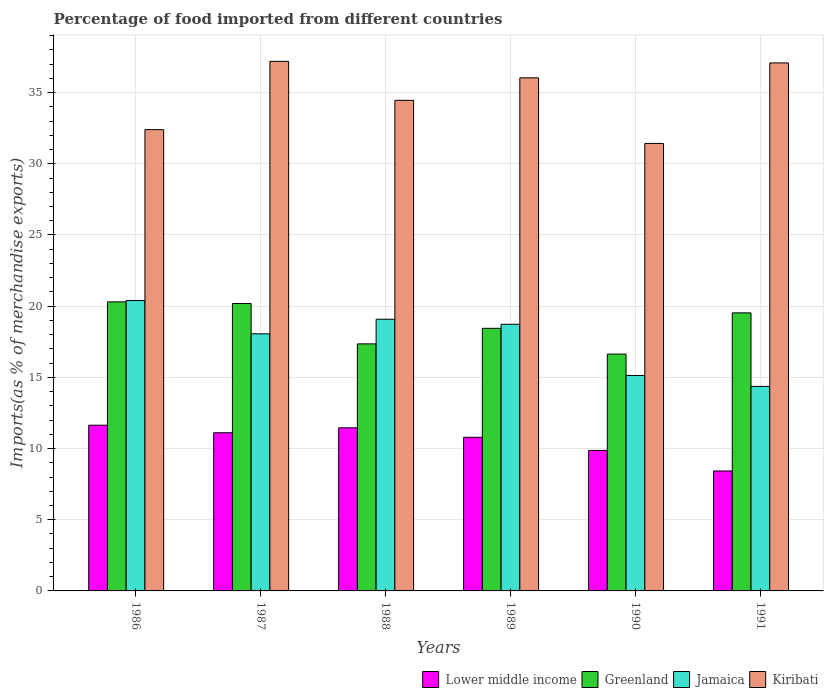How many groups of bars are there?
Your answer should be compact. 6. Are the number of bars per tick equal to the number of legend labels?
Make the answer very short. Yes. Are the number of bars on each tick of the X-axis equal?
Make the answer very short. Yes. How many bars are there on the 6th tick from the right?
Provide a succinct answer. 4. What is the percentage of imports to different countries in Kiribati in 1986?
Provide a short and direct response. 32.4. Across all years, what is the maximum percentage of imports to different countries in Kiribati?
Ensure brevity in your answer.  37.2. Across all years, what is the minimum percentage of imports to different countries in Kiribati?
Ensure brevity in your answer.  31.43. What is the total percentage of imports to different countries in Kiribati in the graph?
Offer a very short reply. 208.61. What is the difference between the percentage of imports to different countries in Kiribati in 1986 and that in 1991?
Provide a succinct answer. -4.68. What is the difference between the percentage of imports to different countries in Greenland in 1989 and the percentage of imports to different countries in Lower middle income in 1990?
Keep it short and to the point. 8.58. What is the average percentage of imports to different countries in Jamaica per year?
Make the answer very short. 17.63. In the year 1991, what is the difference between the percentage of imports to different countries in Greenland and percentage of imports to different countries in Jamaica?
Your response must be concise. 5.16. In how many years, is the percentage of imports to different countries in Jamaica greater than 12 %?
Provide a short and direct response. 6. What is the ratio of the percentage of imports to different countries in Lower middle income in 1986 to that in 1989?
Your response must be concise. 1.08. Is the difference between the percentage of imports to different countries in Greenland in 1987 and 1989 greater than the difference between the percentage of imports to different countries in Jamaica in 1987 and 1989?
Your answer should be very brief. Yes. What is the difference between the highest and the second highest percentage of imports to different countries in Kiribati?
Your response must be concise. 0.11. What is the difference between the highest and the lowest percentage of imports to different countries in Jamaica?
Offer a very short reply. 6.03. Is the sum of the percentage of imports to different countries in Lower middle income in 1987 and 1990 greater than the maximum percentage of imports to different countries in Greenland across all years?
Offer a very short reply. Yes. What does the 2nd bar from the left in 1991 represents?
Provide a short and direct response. Greenland. What does the 2nd bar from the right in 1986 represents?
Keep it short and to the point. Jamaica. Is it the case that in every year, the sum of the percentage of imports to different countries in Kiribati and percentage of imports to different countries in Lower middle income is greater than the percentage of imports to different countries in Greenland?
Your answer should be compact. Yes. How many years are there in the graph?
Provide a short and direct response. 6. What is the difference between two consecutive major ticks on the Y-axis?
Make the answer very short. 5. Does the graph contain any zero values?
Your answer should be very brief. No. How many legend labels are there?
Provide a succinct answer. 4. What is the title of the graph?
Keep it short and to the point. Percentage of food imported from different countries. Does "Italy" appear as one of the legend labels in the graph?
Ensure brevity in your answer.  No. What is the label or title of the Y-axis?
Make the answer very short. Imports(as % of merchandise exports). What is the Imports(as % of merchandise exports) in Lower middle income in 1986?
Offer a terse response. 11.64. What is the Imports(as % of merchandise exports) in Greenland in 1986?
Make the answer very short. 20.3. What is the Imports(as % of merchandise exports) of Jamaica in 1986?
Keep it short and to the point. 20.4. What is the Imports(as % of merchandise exports) of Kiribati in 1986?
Make the answer very short. 32.4. What is the Imports(as % of merchandise exports) in Lower middle income in 1987?
Ensure brevity in your answer.  11.11. What is the Imports(as % of merchandise exports) in Greenland in 1987?
Provide a succinct answer. 20.19. What is the Imports(as % of merchandise exports) of Jamaica in 1987?
Provide a short and direct response. 18.06. What is the Imports(as % of merchandise exports) of Kiribati in 1987?
Ensure brevity in your answer.  37.2. What is the Imports(as % of merchandise exports) in Lower middle income in 1988?
Keep it short and to the point. 11.46. What is the Imports(as % of merchandise exports) of Greenland in 1988?
Provide a short and direct response. 17.35. What is the Imports(as % of merchandise exports) in Jamaica in 1988?
Keep it short and to the point. 19.08. What is the Imports(as % of merchandise exports) in Kiribati in 1988?
Your response must be concise. 34.46. What is the Imports(as % of merchandise exports) in Lower middle income in 1989?
Offer a very short reply. 10.79. What is the Imports(as % of merchandise exports) in Greenland in 1989?
Make the answer very short. 18.45. What is the Imports(as % of merchandise exports) in Jamaica in 1989?
Your response must be concise. 18.73. What is the Imports(as % of merchandise exports) in Kiribati in 1989?
Your answer should be very brief. 36.04. What is the Imports(as % of merchandise exports) of Lower middle income in 1990?
Ensure brevity in your answer.  9.87. What is the Imports(as % of merchandise exports) in Greenland in 1990?
Your answer should be compact. 16.64. What is the Imports(as % of merchandise exports) of Jamaica in 1990?
Offer a terse response. 15.13. What is the Imports(as % of merchandise exports) in Kiribati in 1990?
Your answer should be compact. 31.43. What is the Imports(as % of merchandise exports) of Lower middle income in 1991?
Your response must be concise. 8.43. What is the Imports(as % of merchandise exports) of Greenland in 1991?
Provide a short and direct response. 19.53. What is the Imports(as % of merchandise exports) of Jamaica in 1991?
Your answer should be compact. 14.37. What is the Imports(as % of merchandise exports) in Kiribati in 1991?
Provide a succinct answer. 37.09. Across all years, what is the maximum Imports(as % of merchandise exports) in Lower middle income?
Your answer should be very brief. 11.64. Across all years, what is the maximum Imports(as % of merchandise exports) in Greenland?
Provide a succinct answer. 20.3. Across all years, what is the maximum Imports(as % of merchandise exports) of Jamaica?
Offer a very short reply. 20.4. Across all years, what is the maximum Imports(as % of merchandise exports) in Kiribati?
Provide a short and direct response. 37.2. Across all years, what is the minimum Imports(as % of merchandise exports) in Lower middle income?
Your answer should be compact. 8.43. Across all years, what is the minimum Imports(as % of merchandise exports) in Greenland?
Provide a succinct answer. 16.64. Across all years, what is the minimum Imports(as % of merchandise exports) of Jamaica?
Make the answer very short. 14.37. Across all years, what is the minimum Imports(as % of merchandise exports) in Kiribati?
Give a very brief answer. 31.43. What is the total Imports(as % of merchandise exports) in Lower middle income in the graph?
Provide a short and direct response. 63.29. What is the total Imports(as % of merchandise exports) in Greenland in the graph?
Your answer should be very brief. 112.45. What is the total Imports(as % of merchandise exports) of Jamaica in the graph?
Ensure brevity in your answer.  105.77. What is the total Imports(as % of merchandise exports) of Kiribati in the graph?
Offer a very short reply. 208.61. What is the difference between the Imports(as % of merchandise exports) of Lower middle income in 1986 and that in 1987?
Ensure brevity in your answer.  0.53. What is the difference between the Imports(as % of merchandise exports) in Greenland in 1986 and that in 1987?
Give a very brief answer. 0.11. What is the difference between the Imports(as % of merchandise exports) of Jamaica in 1986 and that in 1987?
Offer a very short reply. 2.34. What is the difference between the Imports(as % of merchandise exports) of Kiribati in 1986 and that in 1987?
Give a very brief answer. -4.8. What is the difference between the Imports(as % of merchandise exports) in Lower middle income in 1986 and that in 1988?
Offer a terse response. 0.18. What is the difference between the Imports(as % of merchandise exports) of Greenland in 1986 and that in 1988?
Offer a terse response. 2.95. What is the difference between the Imports(as % of merchandise exports) in Jamaica in 1986 and that in 1988?
Offer a terse response. 1.31. What is the difference between the Imports(as % of merchandise exports) in Kiribati in 1986 and that in 1988?
Give a very brief answer. -2.06. What is the difference between the Imports(as % of merchandise exports) of Lower middle income in 1986 and that in 1989?
Offer a very short reply. 0.85. What is the difference between the Imports(as % of merchandise exports) in Greenland in 1986 and that in 1989?
Provide a succinct answer. 1.86. What is the difference between the Imports(as % of merchandise exports) in Jamaica in 1986 and that in 1989?
Offer a very short reply. 1.66. What is the difference between the Imports(as % of merchandise exports) in Kiribati in 1986 and that in 1989?
Offer a very short reply. -3.64. What is the difference between the Imports(as % of merchandise exports) in Lower middle income in 1986 and that in 1990?
Offer a very short reply. 1.77. What is the difference between the Imports(as % of merchandise exports) of Greenland in 1986 and that in 1990?
Make the answer very short. 3.67. What is the difference between the Imports(as % of merchandise exports) of Jamaica in 1986 and that in 1990?
Ensure brevity in your answer.  5.26. What is the difference between the Imports(as % of merchandise exports) of Kiribati in 1986 and that in 1990?
Your response must be concise. 0.97. What is the difference between the Imports(as % of merchandise exports) of Lower middle income in 1986 and that in 1991?
Your answer should be compact. 3.21. What is the difference between the Imports(as % of merchandise exports) of Greenland in 1986 and that in 1991?
Keep it short and to the point. 0.77. What is the difference between the Imports(as % of merchandise exports) in Jamaica in 1986 and that in 1991?
Keep it short and to the point. 6.03. What is the difference between the Imports(as % of merchandise exports) of Kiribati in 1986 and that in 1991?
Offer a very short reply. -4.68. What is the difference between the Imports(as % of merchandise exports) of Lower middle income in 1987 and that in 1988?
Provide a succinct answer. -0.35. What is the difference between the Imports(as % of merchandise exports) of Greenland in 1987 and that in 1988?
Offer a terse response. 2.83. What is the difference between the Imports(as % of merchandise exports) of Jamaica in 1987 and that in 1988?
Ensure brevity in your answer.  -1.02. What is the difference between the Imports(as % of merchandise exports) of Kiribati in 1987 and that in 1988?
Make the answer very short. 2.74. What is the difference between the Imports(as % of merchandise exports) of Lower middle income in 1987 and that in 1989?
Offer a terse response. 0.32. What is the difference between the Imports(as % of merchandise exports) in Greenland in 1987 and that in 1989?
Provide a succinct answer. 1.74. What is the difference between the Imports(as % of merchandise exports) in Jamaica in 1987 and that in 1989?
Ensure brevity in your answer.  -0.67. What is the difference between the Imports(as % of merchandise exports) of Kiribati in 1987 and that in 1989?
Offer a terse response. 1.16. What is the difference between the Imports(as % of merchandise exports) of Lower middle income in 1987 and that in 1990?
Your answer should be compact. 1.24. What is the difference between the Imports(as % of merchandise exports) in Greenland in 1987 and that in 1990?
Your response must be concise. 3.55. What is the difference between the Imports(as % of merchandise exports) in Jamaica in 1987 and that in 1990?
Offer a very short reply. 2.92. What is the difference between the Imports(as % of merchandise exports) of Kiribati in 1987 and that in 1990?
Ensure brevity in your answer.  5.76. What is the difference between the Imports(as % of merchandise exports) in Lower middle income in 1987 and that in 1991?
Give a very brief answer. 2.68. What is the difference between the Imports(as % of merchandise exports) in Greenland in 1987 and that in 1991?
Your answer should be very brief. 0.66. What is the difference between the Imports(as % of merchandise exports) of Jamaica in 1987 and that in 1991?
Your answer should be compact. 3.69. What is the difference between the Imports(as % of merchandise exports) in Kiribati in 1987 and that in 1991?
Make the answer very short. 0.11. What is the difference between the Imports(as % of merchandise exports) of Lower middle income in 1988 and that in 1989?
Offer a very short reply. 0.66. What is the difference between the Imports(as % of merchandise exports) in Greenland in 1988 and that in 1989?
Make the answer very short. -1.09. What is the difference between the Imports(as % of merchandise exports) of Jamaica in 1988 and that in 1989?
Give a very brief answer. 0.35. What is the difference between the Imports(as % of merchandise exports) of Kiribati in 1988 and that in 1989?
Keep it short and to the point. -1.58. What is the difference between the Imports(as % of merchandise exports) in Lower middle income in 1988 and that in 1990?
Offer a terse response. 1.59. What is the difference between the Imports(as % of merchandise exports) of Greenland in 1988 and that in 1990?
Keep it short and to the point. 0.72. What is the difference between the Imports(as % of merchandise exports) in Jamaica in 1988 and that in 1990?
Provide a succinct answer. 3.95. What is the difference between the Imports(as % of merchandise exports) of Kiribati in 1988 and that in 1990?
Keep it short and to the point. 3.03. What is the difference between the Imports(as % of merchandise exports) of Lower middle income in 1988 and that in 1991?
Offer a very short reply. 3.03. What is the difference between the Imports(as % of merchandise exports) in Greenland in 1988 and that in 1991?
Give a very brief answer. -2.18. What is the difference between the Imports(as % of merchandise exports) in Jamaica in 1988 and that in 1991?
Your answer should be very brief. 4.72. What is the difference between the Imports(as % of merchandise exports) in Kiribati in 1988 and that in 1991?
Provide a succinct answer. -2.63. What is the difference between the Imports(as % of merchandise exports) in Lower middle income in 1989 and that in 1990?
Your answer should be very brief. 0.92. What is the difference between the Imports(as % of merchandise exports) of Greenland in 1989 and that in 1990?
Provide a short and direct response. 1.81. What is the difference between the Imports(as % of merchandise exports) in Jamaica in 1989 and that in 1990?
Make the answer very short. 3.6. What is the difference between the Imports(as % of merchandise exports) of Kiribati in 1989 and that in 1990?
Ensure brevity in your answer.  4.61. What is the difference between the Imports(as % of merchandise exports) in Lower middle income in 1989 and that in 1991?
Offer a very short reply. 2.36. What is the difference between the Imports(as % of merchandise exports) of Greenland in 1989 and that in 1991?
Provide a succinct answer. -1.08. What is the difference between the Imports(as % of merchandise exports) of Jamaica in 1989 and that in 1991?
Make the answer very short. 4.36. What is the difference between the Imports(as % of merchandise exports) in Kiribati in 1989 and that in 1991?
Ensure brevity in your answer.  -1.05. What is the difference between the Imports(as % of merchandise exports) in Lower middle income in 1990 and that in 1991?
Provide a short and direct response. 1.44. What is the difference between the Imports(as % of merchandise exports) in Greenland in 1990 and that in 1991?
Ensure brevity in your answer.  -2.89. What is the difference between the Imports(as % of merchandise exports) of Jamaica in 1990 and that in 1991?
Provide a short and direct response. 0.77. What is the difference between the Imports(as % of merchandise exports) of Kiribati in 1990 and that in 1991?
Offer a very short reply. -5.65. What is the difference between the Imports(as % of merchandise exports) in Lower middle income in 1986 and the Imports(as % of merchandise exports) in Greenland in 1987?
Your answer should be very brief. -8.55. What is the difference between the Imports(as % of merchandise exports) in Lower middle income in 1986 and the Imports(as % of merchandise exports) in Jamaica in 1987?
Offer a very short reply. -6.42. What is the difference between the Imports(as % of merchandise exports) of Lower middle income in 1986 and the Imports(as % of merchandise exports) of Kiribati in 1987?
Offer a terse response. -25.56. What is the difference between the Imports(as % of merchandise exports) of Greenland in 1986 and the Imports(as % of merchandise exports) of Jamaica in 1987?
Keep it short and to the point. 2.24. What is the difference between the Imports(as % of merchandise exports) in Greenland in 1986 and the Imports(as % of merchandise exports) in Kiribati in 1987?
Ensure brevity in your answer.  -16.89. What is the difference between the Imports(as % of merchandise exports) of Jamaica in 1986 and the Imports(as % of merchandise exports) of Kiribati in 1987?
Ensure brevity in your answer.  -16.8. What is the difference between the Imports(as % of merchandise exports) in Lower middle income in 1986 and the Imports(as % of merchandise exports) in Greenland in 1988?
Your answer should be very brief. -5.71. What is the difference between the Imports(as % of merchandise exports) of Lower middle income in 1986 and the Imports(as % of merchandise exports) of Jamaica in 1988?
Your answer should be compact. -7.44. What is the difference between the Imports(as % of merchandise exports) in Lower middle income in 1986 and the Imports(as % of merchandise exports) in Kiribati in 1988?
Keep it short and to the point. -22.82. What is the difference between the Imports(as % of merchandise exports) in Greenland in 1986 and the Imports(as % of merchandise exports) in Jamaica in 1988?
Give a very brief answer. 1.22. What is the difference between the Imports(as % of merchandise exports) in Greenland in 1986 and the Imports(as % of merchandise exports) in Kiribati in 1988?
Make the answer very short. -14.16. What is the difference between the Imports(as % of merchandise exports) of Jamaica in 1986 and the Imports(as % of merchandise exports) of Kiribati in 1988?
Keep it short and to the point. -14.06. What is the difference between the Imports(as % of merchandise exports) in Lower middle income in 1986 and the Imports(as % of merchandise exports) in Greenland in 1989?
Give a very brief answer. -6.81. What is the difference between the Imports(as % of merchandise exports) of Lower middle income in 1986 and the Imports(as % of merchandise exports) of Jamaica in 1989?
Keep it short and to the point. -7.09. What is the difference between the Imports(as % of merchandise exports) of Lower middle income in 1986 and the Imports(as % of merchandise exports) of Kiribati in 1989?
Your answer should be compact. -24.4. What is the difference between the Imports(as % of merchandise exports) of Greenland in 1986 and the Imports(as % of merchandise exports) of Jamaica in 1989?
Provide a short and direct response. 1.57. What is the difference between the Imports(as % of merchandise exports) of Greenland in 1986 and the Imports(as % of merchandise exports) of Kiribati in 1989?
Offer a very short reply. -15.74. What is the difference between the Imports(as % of merchandise exports) of Jamaica in 1986 and the Imports(as % of merchandise exports) of Kiribati in 1989?
Offer a very short reply. -15.64. What is the difference between the Imports(as % of merchandise exports) of Lower middle income in 1986 and the Imports(as % of merchandise exports) of Greenland in 1990?
Offer a terse response. -5. What is the difference between the Imports(as % of merchandise exports) in Lower middle income in 1986 and the Imports(as % of merchandise exports) in Jamaica in 1990?
Ensure brevity in your answer.  -3.49. What is the difference between the Imports(as % of merchandise exports) in Lower middle income in 1986 and the Imports(as % of merchandise exports) in Kiribati in 1990?
Provide a short and direct response. -19.79. What is the difference between the Imports(as % of merchandise exports) of Greenland in 1986 and the Imports(as % of merchandise exports) of Jamaica in 1990?
Offer a terse response. 5.17. What is the difference between the Imports(as % of merchandise exports) in Greenland in 1986 and the Imports(as % of merchandise exports) in Kiribati in 1990?
Offer a very short reply. -11.13. What is the difference between the Imports(as % of merchandise exports) of Jamaica in 1986 and the Imports(as % of merchandise exports) of Kiribati in 1990?
Offer a very short reply. -11.04. What is the difference between the Imports(as % of merchandise exports) in Lower middle income in 1986 and the Imports(as % of merchandise exports) in Greenland in 1991?
Offer a terse response. -7.89. What is the difference between the Imports(as % of merchandise exports) in Lower middle income in 1986 and the Imports(as % of merchandise exports) in Jamaica in 1991?
Your answer should be compact. -2.73. What is the difference between the Imports(as % of merchandise exports) in Lower middle income in 1986 and the Imports(as % of merchandise exports) in Kiribati in 1991?
Give a very brief answer. -25.45. What is the difference between the Imports(as % of merchandise exports) of Greenland in 1986 and the Imports(as % of merchandise exports) of Jamaica in 1991?
Ensure brevity in your answer.  5.93. What is the difference between the Imports(as % of merchandise exports) of Greenland in 1986 and the Imports(as % of merchandise exports) of Kiribati in 1991?
Give a very brief answer. -16.78. What is the difference between the Imports(as % of merchandise exports) of Jamaica in 1986 and the Imports(as % of merchandise exports) of Kiribati in 1991?
Give a very brief answer. -16.69. What is the difference between the Imports(as % of merchandise exports) in Lower middle income in 1987 and the Imports(as % of merchandise exports) in Greenland in 1988?
Ensure brevity in your answer.  -6.24. What is the difference between the Imports(as % of merchandise exports) of Lower middle income in 1987 and the Imports(as % of merchandise exports) of Jamaica in 1988?
Make the answer very short. -7.97. What is the difference between the Imports(as % of merchandise exports) in Lower middle income in 1987 and the Imports(as % of merchandise exports) in Kiribati in 1988?
Your answer should be compact. -23.35. What is the difference between the Imports(as % of merchandise exports) in Greenland in 1987 and the Imports(as % of merchandise exports) in Jamaica in 1988?
Keep it short and to the point. 1.1. What is the difference between the Imports(as % of merchandise exports) of Greenland in 1987 and the Imports(as % of merchandise exports) of Kiribati in 1988?
Your answer should be compact. -14.27. What is the difference between the Imports(as % of merchandise exports) in Jamaica in 1987 and the Imports(as % of merchandise exports) in Kiribati in 1988?
Your answer should be compact. -16.4. What is the difference between the Imports(as % of merchandise exports) of Lower middle income in 1987 and the Imports(as % of merchandise exports) of Greenland in 1989?
Your answer should be very brief. -7.34. What is the difference between the Imports(as % of merchandise exports) in Lower middle income in 1987 and the Imports(as % of merchandise exports) in Jamaica in 1989?
Your response must be concise. -7.62. What is the difference between the Imports(as % of merchandise exports) of Lower middle income in 1987 and the Imports(as % of merchandise exports) of Kiribati in 1989?
Your answer should be compact. -24.93. What is the difference between the Imports(as % of merchandise exports) in Greenland in 1987 and the Imports(as % of merchandise exports) in Jamaica in 1989?
Provide a succinct answer. 1.46. What is the difference between the Imports(as % of merchandise exports) in Greenland in 1987 and the Imports(as % of merchandise exports) in Kiribati in 1989?
Your answer should be compact. -15.85. What is the difference between the Imports(as % of merchandise exports) of Jamaica in 1987 and the Imports(as % of merchandise exports) of Kiribati in 1989?
Your answer should be compact. -17.98. What is the difference between the Imports(as % of merchandise exports) of Lower middle income in 1987 and the Imports(as % of merchandise exports) of Greenland in 1990?
Ensure brevity in your answer.  -5.53. What is the difference between the Imports(as % of merchandise exports) in Lower middle income in 1987 and the Imports(as % of merchandise exports) in Jamaica in 1990?
Give a very brief answer. -4.02. What is the difference between the Imports(as % of merchandise exports) of Lower middle income in 1987 and the Imports(as % of merchandise exports) of Kiribati in 1990?
Provide a succinct answer. -20.32. What is the difference between the Imports(as % of merchandise exports) of Greenland in 1987 and the Imports(as % of merchandise exports) of Jamaica in 1990?
Keep it short and to the point. 5.05. What is the difference between the Imports(as % of merchandise exports) in Greenland in 1987 and the Imports(as % of merchandise exports) in Kiribati in 1990?
Provide a short and direct response. -11.25. What is the difference between the Imports(as % of merchandise exports) in Jamaica in 1987 and the Imports(as % of merchandise exports) in Kiribati in 1990?
Ensure brevity in your answer.  -13.37. What is the difference between the Imports(as % of merchandise exports) in Lower middle income in 1987 and the Imports(as % of merchandise exports) in Greenland in 1991?
Your response must be concise. -8.42. What is the difference between the Imports(as % of merchandise exports) of Lower middle income in 1987 and the Imports(as % of merchandise exports) of Jamaica in 1991?
Your answer should be very brief. -3.26. What is the difference between the Imports(as % of merchandise exports) in Lower middle income in 1987 and the Imports(as % of merchandise exports) in Kiribati in 1991?
Your response must be concise. -25.98. What is the difference between the Imports(as % of merchandise exports) in Greenland in 1987 and the Imports(as % of merchandise exports) in Jamaica in 1991?
Your response must be concise. 5.82. What is the difference between the Imports(as % of merchandise exports) in Greenland in 1987 and the Imports(as % of merchandise exports) in Kiribati in 1991?
Give a very brief answer. -16.9. What is the difference between the Imports(as % of merchandise exports) in Jamaica in 1987 and the Imports(as % of merchandise exports) in Kiribati in 1991?
Give a very brief answer. -19.03. What is the difference between the Imports(as % of merchandise exports) of Lower middle income in 1988 and the Imports(as % of merchandise exports) of Greenland in 1989?
Ensure brevity in your answer.  -6.99. What is the difference between the Imports(as % of merchandise exports) in Lower middle income in 1988 and the Imports(as % of merchandise exports) in Jamaica in 1989?
Provide a succinct answer. -7.27. What is the difference between the Imports(as % of merchandise exports) of Lower middle income in 1988 and the Imports(as % of merchandise exports) of Kiribati in 1989?
Give a very brief answer. -24.58. What is the difference between the Imports(as % of merchandise exports) in Greenland in 1988 and the Imports(as % of merchandise exports) in Jamaica in 1989?
Keep it short and to the point. -1.38. What is the difference between the Imports(as % of merchandise exports) of Greenland in 1988 and the Imports(as % of merchandise exports) of Kiribati in 1989?
Ensure brevity in your answer.  -18.69. What is the difference between the Imports(as % of merchandise exports) of Jamaica in 1988 and the Imports(as % of merchandise exports) of Kiribati in 1989?
Your answer should be very brief. -16.96. What is the difference between the Imports(as % of merchandise exports) of Lower middle income in 1988 and the Imports(as % of merchandise exports) of Greenland in 1990?
Offer a terse response. -5.18. What is the difference between the Imports(as % of merchandise exports) of Lower middle income in 1988 and the Imports(as % of merchandise exports) of Jamaica in 1990?
Your response must be concise. -3.68. What is the difference between the Imports(as % of merchandise exports) of Lower middle income in 1988 and the Imports(as % of merchandise exports) of Kiribati in 1990?
Ensure brevity in your answer.  -19.98. What is the difference between the Imports(as % of merchandise exports) in Greenland in 1988 and the Imports(as % of merchandise exports) in Jamaica in 1990?
Offer a terse response. 2.22. What is the difference between the Imports(as % of merchandise exports) in Greenland in 1988 and the Imports(as % of merchandise exports) in Kiribati in 1990?
Offer a very short reply. -14.08. What is the difference between the Imports(as % of merchandise exports) in Jamaica in 1988 and the Imports(as % of merchandise exports) in Kiribati in 1990?
Provide a short and direct response. -12.35. What is the difference between the Imports(as % of merchandise exports) of Lower middle income in 1988 and the Imports(as % of merchandise exports) of Greenland in 1991?
Offer a very short reply. -8.07. What is the difference between the Imports(as % of merchandise exports) in Lower middle income in 1988 and the Imports(as % of merchandise exports) in Jamaica in 1991?
Your response must be concise. -2.91. What is the difference between the Imports(as % of merchandise exports) in Lower middle income in 1988 and the Imports(as % of merchandise exports) in Kiribati in 1991?
Give a very brief answer. -25.63. What is the difference between the Imports(as % of merchandise exports) in Greenland in 1988 and the Imports(as % of merchandise exports) in Jamaica in 1991?
Ensure brevity in your answer.  2.99. What is the difference between the Imports(as % of merchandise exports) in Greenland in 1988 and the Imports(as % of merchandise exports) in Kiribati in 1991?
Ensure brevity in your answer.  -19.73. What is the difference between the Imports(as % of merchandise exports) in Jamaica in 1988 and the Imports(as % of merchandise exports) in Kiribati in 1991?
Provide a succinct answer. -18. What is the difference between the Imports(as % of merchandise exports) of Lower middle income in 1989 and the Imports(as % of merchandise exports) of Greenland in 1990?
Give a very brief answer. -5.85. What is the difference between the Imports(as % of merchandise exports) in Lower middle income in 1989 and the Imports(as % of merchandise exports) in Jamaica in 1990?
Offer a terse response. -4.34. What is the difference between the Imports(as % of merchandise exports) of Lower middle income in 1989 and the Imports(as % of merchandise exports) of Kiribati in 1990?
Your answer should be compact. -20.64. What is the difference between the Imports(as % of merchandise exports) of Greenland in 1989 and the Imports(as % of merchandise exports) of Jamaica in 1990?
Give a very brief answer. 3.31. What is the difference between the Imports(as % of merchandise exports) in Greenland in 1989 and the Imports(as % of merchandise exports) in Kiribati in 1990?
Make the answer very short. -12.99. What is the difference between the Imports(as % of merchandise exports) in Jamaica in 1989 and the Imports(as % of merchandise exports) in Kiribati in 1990?
Make the answer very short. -12.7. What is the difference between the Imports(as % of merchandise exports) in Lower middle income in 1989 and the Imports(as % of merchandise exports) in Greenland in 1991?
Your answer should be compact. -8.74. What is the difference between the Imports(as % of merchandise exports) in Lower middle income in 1989 and the Imports(as % of merchandise exports) in Jamaica in 1991?
Your response must be concise. -3.58. What is the difference between the Imports(as % of merchandise exports) of Lower middle income in 1989 and the Imports(as % of merchandise exports) of Kiribati in 1991?
Provide a succinct answer. -26.29. What is the difference between the Imports(as % of merchandise exports) of Greenland in 1989 and the Imports(as % of merchandise exports) of Jamaica in 1991?
Offer a very short reply. 4.08. What is the difference between the Imports(as % of merchandise exports) of Greenland in 1989 and the Imports(as % of merchandise exports) of Kiribati in 1991?
Keep it short and to the point. -18.64. What is the difference between the Imports(as % of merchandise exports) in Jamaica in 1989 and the Imports(as % of merchandise exports) in Kiribati in 1991?
Provide a short and direct response. -18.36. What is the difference between the Imports(as % of merchandise exports) of Lower middle income in 1990 and the Imports(as % of merchandise exports) of Greenland in 1991?
Keep it short and to the point. -9.66. What is the difference between the Imports(as % of merchandise exports) in Lower middle income in 1990 and the Imports(as % of merchandise exports) in Jamaica in 1991?
Ensure brevity in your answer.  -4.5. What is the difference between the Imports(as % of merchandise exports) in Lower middle income in 1990 and the Imports(as % of merchandise exports) in Kiribati in 1991?
Make the answer very short. -27.22. What is the difference between the Imports(as % of merchandise exports) in Greenland in 1990 and the Imports(as % of merchandise exports) in Jamaica in 1991?
Your answer should be very brief. 2.27. What is the difference between the Imports(as % of merchandise exports) in Greenland in 1990 and the Imports(as % of merchandise exports) in Kiribati in 1991?
Offer a terse response. -20.45. What is the difference between the Imports(as % of merchandise exports) in Jamaica in 1990 and the Imports(as % of merchandise exports) in Kiribati in 1991?
Make the answer very short. -21.95. What is the average Imports(as % of merchandise exports) in Lower middle income per year?
Keep it short and to the point. 10.55. What is the average Imports(as % of merchandise exports) in Greenland per year?
Offer a very short reply. 18.74. What is the average Imports(as % of merchandise exports) of Jamaica per year?
Give a very brief answer. 17.63. What is the average Imports(as % of merchandise exports) of Kiribati per year?
Ensure brevity in your answer.  34.77. In the year 1986, what is the difference between the Imports(as % of merchandise exports) of Lower middle income and Imports(as % of merchandise exports) of Greenland?
Provide a short and direct response. -8.66. In the year 1986, what is the difference between the Imports(as % of merchandise exports) of Lower middle income and Imports(as % of merchandise exports) of Jamaica?
Offer a terse response. -8.76. In the year 1986, what is the difference between the Imports(as % of merchandise exports) of Lower middle income and Imports(as % of merchandise exports) of Kiribati?
Your answer should be compact. -20.76. In the year 1986, what is the difference between the Imports(as % of merchandise exports) in Greenland and Imports(as % of merchandise exports) in Jamaica?
Your answer should be compact. -0.09. In the year 1986, what is the difference between the Imports(as % of merchandise exports) of Greenland and Imports(as % of merchandise exports) of Kiribati?
Offer a very short reply. -12.1. In the year 1986, what is the difference between the Imports(as % of merchandise exports) in Jamaica and Imports(as % of merchandise exports) in Kiribati?
Offer a terse response. -12.01. In the year 1987, what is the difference between the Imports(as % of merchandise exports) in Lower middle income and Imports(as % of merchandise exports) in Greenland?
Ensure brevity in your answer.  -9.08. In the year 1987, what is the difference between the Imports(as % of merchandise exports) of Lower middle income and Imports(as % of merchandise exports) of Jamaica?
Your response must be concise. -6.95. In the year 1987, what is the difference between the Imports(as % of merchandise exports) of Lower middle income and Imports(as % of merchandise exports) of Kiribati?
Offer a terse response. -26.09. In the year 1987, what is the difference between the Imports(as % of merchandise exports) in Greenland and Imports(as % of merchandise exports) in Jamaica?
Provide a short and direct response. 2.13. In the year 1987, what is the difference between the Imports(as % of merchandise exports) in Greenland and Imports(as % of merchandise exports) in Kiribati?
Your response must be concise. -17.01. In the year 1987, what is the difference between the Imports(as % of merchandise exports) in Jamaica and Imports(as % of merchandise exports) in Kiribati?
Your answer should be very brief. -19.14. In the year 1988, what is the difference between the Imports(as % of merchandise exports) of Lower middle income and Imports(as % of merchandise exports) of Greenland?
Offer a very short reply. -5.9. In the year 1988, what is the difference between the Imports(as % of merchandise exports) of Lower middle income and Imports(as % of merchandise exports) of Jamaica?
Offer a very short reply. -7.63. In the year 1988, what is the difference between the Imports(as % of merchandise exports) in Lower middle income and Imports(as % of merchandise exports) in Kiribati?
Make the answer very short. -23. In the year 1988, what is the difference between the Imports(as % of merchandise exports) of Greenland and Imports(as % of merchandise exports) of Jamaica?
Keep it short and to the point. -1.73. In the year 1988, what is the difference between the Imports(as % of merchandise exports) in Greenland and Imports(as % of merchandise exports) in Kiribati?
Offer a terse response. -17.11. In the year 1988, what is the difference between the Imports(as % of merchandise exports) in Jamaica and Imports(as % of merchandise exports) in Kiribati?
Give a very brief answer. -15.38. In the year 1989, what is the difference between the Imports(as % of merchandise exports) of Lower middle income and Imports(as % of merchandise exports) of Greenland?
Offer a terse response. -7.65. In the year 1989, what is the difference between the Imports(as % of merchandise exports) of Lower middle income and Imports(as % of merchandise exports) of Jamaica?
Ensure brevity in your answer.  -7.94. In the year 1989, what is the difference between the Imports(as % of merchandise exports) of Lower middle income and Imports(as % of merchandise exports) of Kiribati?
Ensure brevity in your answer.  -25.25. In the year 1989, what is the difference between the Imports(as % of merchandise exports) in Greenland and Imports(as % of merchandise exports) in Jamaica?
Keep it short and to the point. -0.29. In the year 1989, what is the difference between the Imports(as % of merchandise exports) of Greenland and Imports(as % of merchandise exports) of Kiribati?
Your answer should be very brief. -17.59. In the year 1989, what is the difference between the Imports(as % of merchandise exports) in Jamaica and Imports(as % of merchandise exports) in Kiribati?
Ensure brevity in your answer.  -17.31. In the year 1990, what is the difference between the Imports(as % of merchandise exports) of Lower middle income and Imports(as % of merchandise exports) of Greenland?
Make the answer very short. -6.77. In the year 1990, what is the difference between the Imports(as % of merchandise exports) in Lower middle income and Imports(as % of merchandise exports) in Jamaica?
Offer a very short reply. -5.27. In the year 1990, what is the difference between the Imports(as % of merchandise exports) in Lower middle income and Imports(as % of merchandise exports) in Kiribati?
Keep it short and to the point. -21.56. In the year 1990, what is the difference between the Imports(as % of merchandise exports) in Greenland and Imports(as % of merchandise exports) in Jamaica?
Your answer should be very brief. 1.5. In the year 1990, what is the difference between the Imports(as % of merchandise exports) in Greenland and Imports(as % of merchandise exports) in Kiribati?
Your answer should be compact. -14.8. In the year 1990, what is the difference between the Imports(as % of merchandise exports) of Jamaica and Imports(as % of merchandise exports) of Kiribati?
Provide a succinct answer. -16.3. In the year 1991, what is the difference between the Imports(as % of merchandise exports) of Lower middle income and Imports(as % of merchandise exports) of Greenland?
Make the answer very short. -11.1. In the year 1991, what is the difference between the Imports(as % of merchandise exports) in Lower middle income and Imports(as % of merchandise exports) in Jamaica?
Provide a short and direct response. -5.94. In the year 1991, what is the difference between the Imports(as % of merchandise exports) of Lower middle income and Imports(as % of merchandise exports) of Kiribati?
Your answer should be very brief. -28.66. In the year 1991, what is the difference between the Imports(as % of merchandise exports) in Greenland and Imports(as % of merchandise exports) in Jamaica?
Your answer should be very brief. 5.16. In the year 1991, what is the difference between the Imports(as % of merchandise exports) in Greenland and Imports(as % of merchandise exports) in Kiribati?
Your answer should be compact. -17.56. In the year 1991, what is the difference between the Imports(as % of merchandise exports) in Jamaica and Imports(as % of merchandise exports) in Kiribati?
Provide a short and direct response. -22.72. What is the ratio of the Imports(as % of merchandise exports) of Lower middle income in 1986 to that in 1987?
Make the answer very short. 1.05. What is the ratio of the Imports(as % of merchandise exports) of Jamaica in 1986 to that in 1987?
Offer a very short reply. 1.13. What is the ratio of the Imports(as % of merchandise exports) in Kiribati in 1986 to that in 1987?
Make the answer very short. 0.87. What is the ratio of the Imports(as % of merchandise exports) in Greenland in 1986 to that in 1988?
Your answer should be compact. 1.17. What is the ratio of the Imports(as % of merchandise exports) in Jamaica in 1986 to that in 1988?
Keep it short and to the point. 1.07. What is the ratio of the Imports(as % of merchandise exports) of Kiribati in 1986 to that in 1988?
Ensure brevity in your answer.  0.94. What is the ratio of the Imports(as % of merchandise exports) in Lower middle income in 1986 to that in 1989?
Ensure brevity in your answer.  1.08. What is the ratio of the Imports(as % of merchandise exports) in Greenland in 1986 to that in 1989?
Offer a terse response. 1.1. What is the ratio of the Imports(as % of merchandise exports) of Jamaica in 1986 to that in 1989?
Your response must be concise. 1.09. What is the ratio of the Imports(as % of merchandise exports) of Kiribati in 1986 to that in 1989?
Your answer should be very brief. 0.9. What is the ratio of the Imports(as % of merchandise exports) of Lower middle income in 1986 to that in 1990?
Your response must be concise. 1.18. What is the ratio of the Imports(as % of merchandise exports) of Greenland in 1986 to that in 1990?
Keep it short and to the point. 1.22. What is the ratio of the Imports(as % of merchandise exports) in Jamaica in 1986 to that in 1990?
Provide a succinct answer. 1.35. What is the ratio of the Imports(as % of merchandise exports) in Kiribati in 1986 to that in 1990?
Your response must be concise. 1.03. What is the ratio of the Imports(as % of merchandise exports) in Lower middle income in 1986 to that in 1991?
Your response must be concise. 1.38. What is the ratio of the Imports(as % of merchandise exports) in Greenland in 1986 to that in 1991?
Provide a succinct answer. 1.04. What is the ratio of the Imports(as % of merchandise exports) of Jamaica in 1986 to that in 1991?
Offer a terse response. 1.42. What is the ratio of the Imports(as % of merchandise exports) of Kiribati in 1986 to that in 1991?
Provide a succinct answer. 0.87. What is the ratio of the Imports(as % of merchandise exports) in Lower middle income in 1987 to that in 1988?
Offer a very short reply. 0.97. What is the ratio of the Imports(as % of merchandise exports) in Greenland in 1987 to that in 1988?
Give a very brief answer. 1.16. What is the ratio of the Imports(as % of merchandise exports) of Jamaica in 1987 to that in 1988?
Offer a very short reply. 0.95. What is the ratio of the Imports(as % of merchandise exports) of Kiribati in 1987 to that in 1988?
Provide a short and direct response. 1.08. What is the ratio of the Imports(as % of merchandise exports) of Lower middle income in 1987 to that in 1989?
Offer a very short reply. 1.03. What is the ratio of the Imports(as % of merchandise exports) of Greenland in 1987 to that in 1989?
Your answer should be compact. 1.09. What is the ratio of the Imports(as % of merchandise exports) in Jamaica in 1987 to that in 1989?
Your answer should be compact. 0.96. What is the ratio of the Imports(as % of merchandise exports) of Kiribati in 1987 to that in 1989?
Your answer should be very brief. 1.03. What is the ratio of the Imports(as % of merchandise exports) in Lower middle income in 1987 to that in 1990?
Offer a terse response. 1.13. What is the ratio of the Imports(as % of merchandise exports) of Greenland in 1987 to that in 1990?
Provide a short and direct response. 1.21. What is the ratio of the Imports(as % of merchandise exports) of Jamaica in 1987 to that in 1990?
Provide a short and direct response. 1.19. What is the ratio of the Imports(as % of merchandise exports) in Kiribati in 1987 to that in 1990?
Keep it short and to the point. 1.18. What is the ratio of the Imports(as % of merchandise exports) in Lower middle income in 1987 to that in 1991?
Your answer should be compact. 1.32. What is the ratio of the Imports(as % of merchandise exports) in Greenland in 1987 to that in 1991?
Your response must be concise. 1.03. What is the ratio of the Imports(as % of merchandise exports) in Jamaica in 1987 to that in 1991?
Make the answer very short. 1.26. What is the ratio of the Imports(as % of merchandise exports) in Kiribati in 1987 to that in 1991?
Your answer should be very brief. 1. What is the ratio of the Imports(as % of merchandise exports) in Lower middle income in 1988 to that in 1989?
Provide a succinct answer. 1.06. What is the ratio of the Imports(as % of merchandise exports) in Greenland in 1988 to that in 1989?
Provide a succinct answer. 0.94. What is the ratio of the Imports(as % of merchandise exports) in Jamaica in 1988 to that in 1989?
Make the answer very short. 1.02. What is the ratio of the Imports(as % of merchandise exports) in Kiribati in 1988 to that in 1989?
Your answer should be very brief. 0.96. What is the ratio of the Imports(as % of merchandise exports) of Lower middle income in 1988 to that in 1990?
Provide a succinct answer. 1.16. What is the ratio of the Imports(as % of merchandise exports) in Greenland in 1988 to that in 1990?
Provide a succinct answer. 1.04. What is the ratio of the Imports(as % of merchandise exports) of Jamaica in 1988 to that in 1990?
Your response must be concise. 1.26. What is the ratio of the Imports(as % of merchandise exports) of Kiribati in 1988 to that in 1990?
Make the answer very short. 1.1. What is the ratio of the Imports(as % of merchandise exports) of Lower middle income in 1988 to that in 1991?
Offer a terse response. 1.36. What is the ratio of the Imports(as % of merchandise exports) in Greenland in 1988 to that in 1991?
Make the answer very short. 0.89. What is the ratio of the Imports(as % of merchandise exports) of Jamaica in 1988 to that in 1991?
Ensure brevity in your answer.  1.33. What is the ratio of the Imports(as % of merchandise exports) in Kiribati in 1988 to that in 1991?
Your answer should be very brief. 0.93. What is the ratio of the Imports(as % of merchandise exports) in Lower middle income in 1989 to that in 1990?
Your answer should be very brief. 1.09. What is the ratio of the Imports(as % of merchandise exports) of Greenland in 1989 to that in 1990?
Offer a very short reply. 1.11. What is the ratio of the Imports(as % of merchandise exports) in Jamaica in 1989 to that in 1990?
Offer a very short reply. 1.24. What is the ratio of the Imports(as % of merchandise exports) of Kiribati in 1989 to that in 1990?
Make the answer very short. 1.15. What is the ratio of the Imports(as % of merchandise exports) of Lower middle income in 1989 to that in 1991?
Make the answer very short. 1.28. What is the ratio of the Imports(as % of merchandise exports) in Greenland in 1989 to that in 1991?
Ensure brevity in your answer.  0.94. What is the ratio of the Imports(as % of merchandise exports) of Jamaica in 1989 to that in 1991?
Make the answer very short. 1.3. What is the ratio of the Imports(as % of merchandise exports) of Kiribati in 1989 to that in 1991?
Offer a terse response. 0.97. What is the ratio of the Imports(as % of merchandise exports) of Lower middle income in 1990 to that in 1991?
Offer a terse response. 1.17. What is the ratio of the Imports(as % of merchandise exports) in Greenland in 1990 to that in 1991?
Offer a terse response. 0.85. What is the ratio of the Imports(as % of merchandise exports) of Jamaica in 1990 to that in 1991?
Offer a very short reply. 1.05. What is the ratio of the Imports(as % of merchandise exports) in Kiribati in 1990 to that in 1991?
Keep it short and to the point. 0.85. What is the difference between the highest and the second highest Imports(as % of merchandise exports) of Lower middle income?
Your answer should be very brief. 0.18. What is the difference between the highest and the second highest Imports(as % of merchandise exports) in Greenland?
Your answer should be compact. 0.11. What is the difference between the highest and the second highest Imports(as % of merchandise exports) in Jamaica?
Provide a short and direct response. 1.31. What is the difference between the highest and the second highest Imports(as % of merchandise exports) in Kiribati?
Your response must be concise. 0.11. What is the difference between the highest and the lowest Imports(as % of merchandise exports) in Lower middle income?
Your answer should be very brief. 3.21. What is the difference between the highest and the lowest Imports(as % of merchandise exports) in Greenland?
Your answer should be very brief. 3.67. What is the difference between the highest and the lowest Imports(as % of merchandise exports) of Jamaica?
Your answer should be very brief. 6.03. What is the difference between the highest and the lowest Imports(as % of merchandise exports) of Kiribati?
Give a very brief answer. 5.76. 